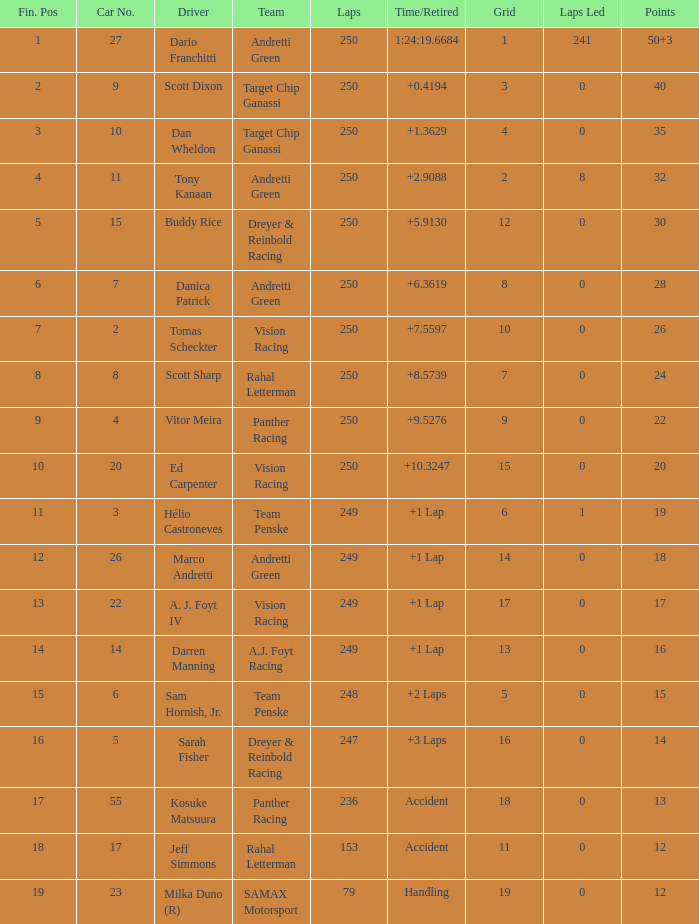Name the total number of fin pos for 12 points of accident 1.0. 